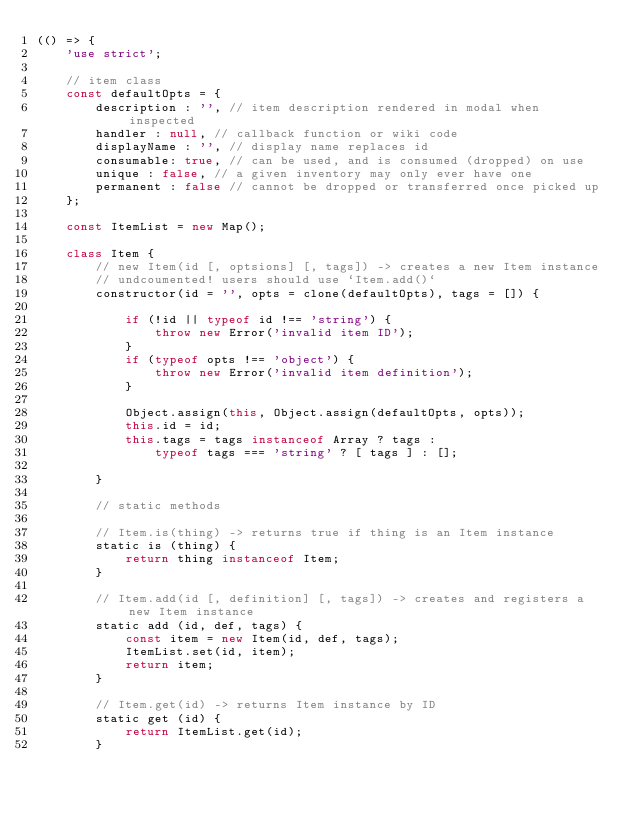<code> <loc_0><loc_0><loc_500><loc_500><_JavaScript_>(() => {
    'use strict';

    // item class
    const defaultOpts = {
        description : '', // item description rendered in modal when inspected
        handler : null, // callback function or wiki code
        displayName : '', // display name replaces id
        consumable: true, // can be used, and is consumed (dropped) on use
        unique : false, // a given inventory may only ever have one
        permanent : false // cannot be dropped or transferred once picked up
    };

    const ItemList = new Map();

    class Item {
        // new Item(id [, optsions] [, tags]) -> creates a new Item instance
        // undcoumented! users should use `Item.add()`
        constructor(id = '', opts = clone(defaultOpts), tags = []) {

            if (!id || typeof id !== 'string') {
                throw new Error('invalid item ID');
            }
            if (typeof opts !== 'object') {
                throw new Error('invalid item definition');
            }
            
            Object.assign(this, Object.assign(defaultOpts, opts));
            this.id = id;
            this.tags = tags instanceof Array ? tags : 
                typeof tags === 'string' ? [ tags ] : [];

        }

        // static methods

        // Item.is(thing) -> returns true if thing is an Item instance
        static is (thing) {
            return thing instanceof Item;
        }

        // Item.add(id [, definition] [, tags]) -> creates and registers a new Item instance
        static add (id, def, tags) {
            const item = new Item(id, def, tags);
            ItemList.set(id, item);
            return item;
        }

        // Item.get(id) -> returns Item instance by ID
        static get (id) {
            return ItemList.get(id);
        }
</code> 